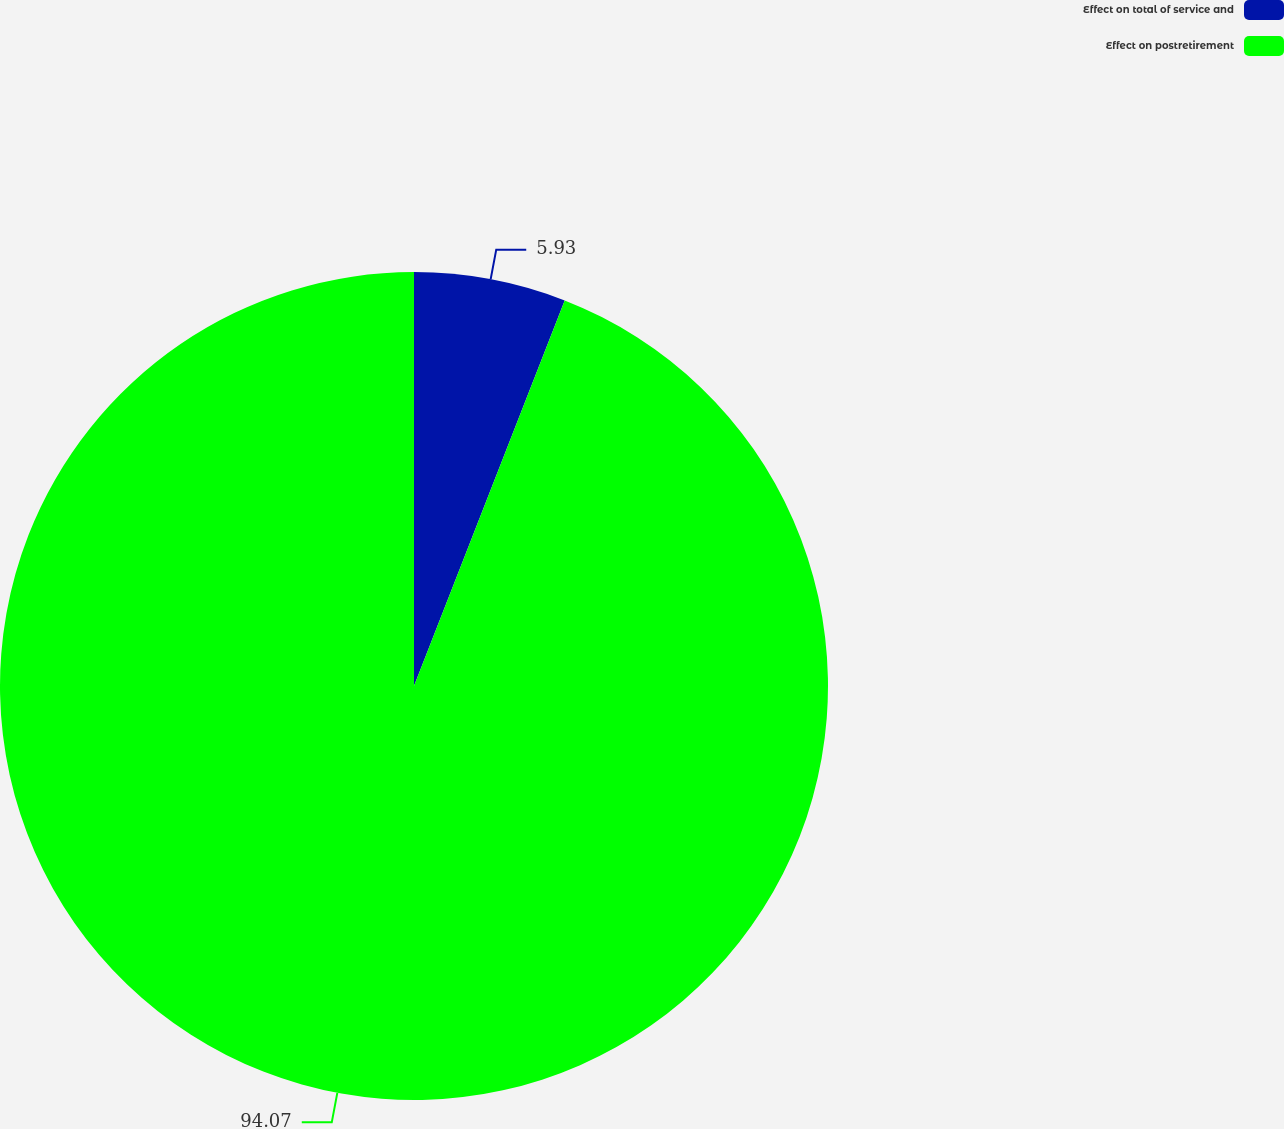<chart> <loc_0><loc_0><loc_500><loc_500><pie_chart><fcel>Effect on total of service and<fcel>Effect on postretirement<nl><fcel>5.93%<fcel>94.07%<nl></chart> 